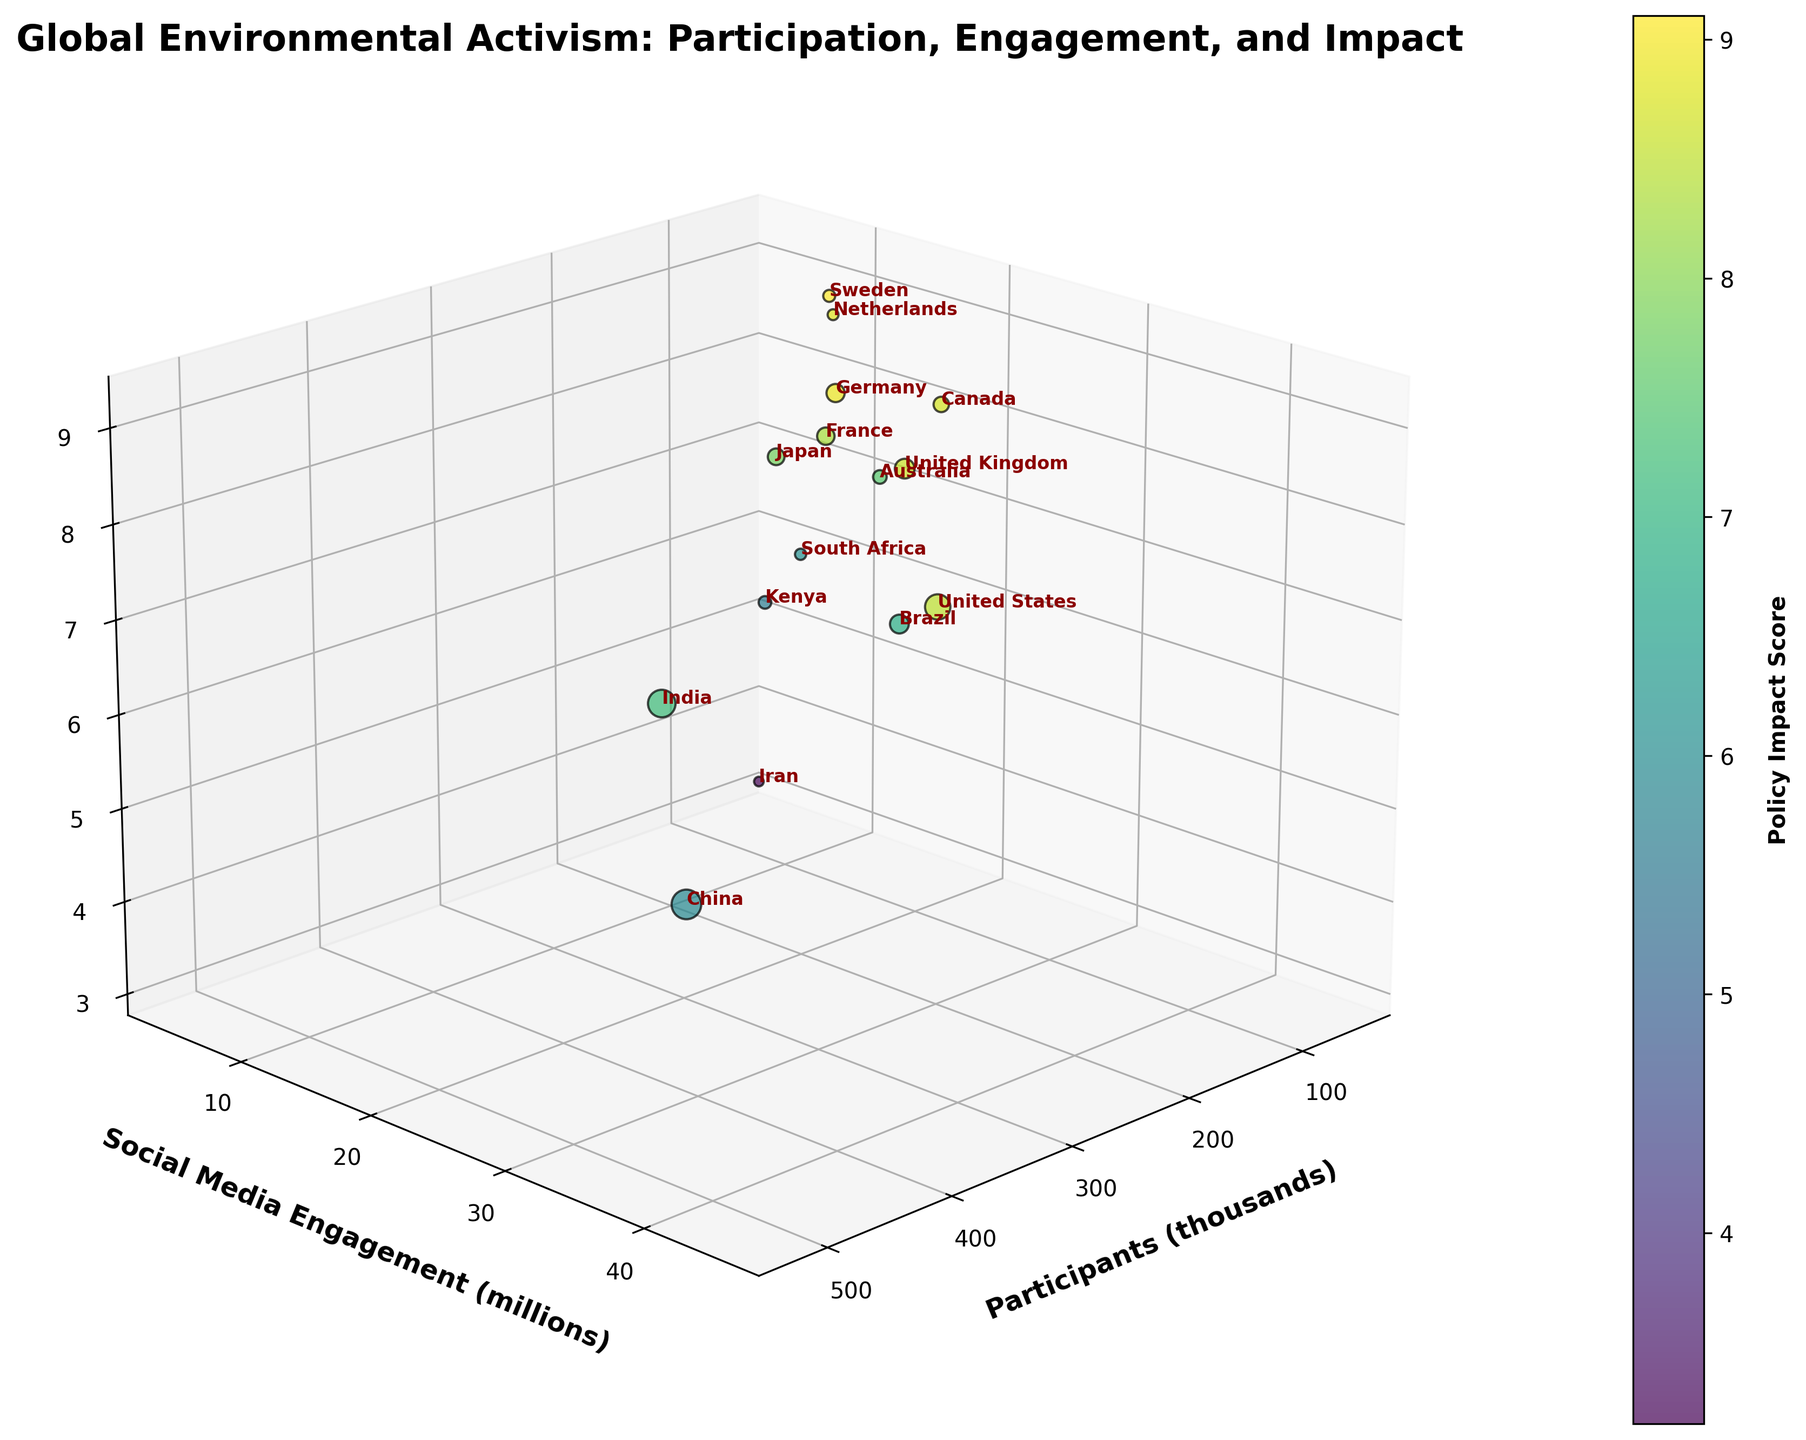What's the title of the figure? The title is prominently displayed at the top of the figure in bold text.
Answer: Global Environmental Activism: Participation, Engagement, and Impact Which country has the highest number of participants? The participants are represented on the x-axis, and the data point for China is the furthest to the right.
Answer: China What is the policy impact score for Sweden? Sweden's data point can be located by its label, and the z-axis value tells us the policy impact score.
Answer: 9.1 How many countries have a social media engagement above 20 million? The y-axis represents social media engagement, so we count the number of data points above 20 on the y-axis.
Answer: 7 Which country has the lowest policy impact score? The policy impact score is shown on the z-axis, and Iran is identified as the lowest point.
Answer: Iran Compare the social media engagement of India and United States. Look at the y-axis values for India and the United States, identified by their labels. India has 32 million, and the United States has 45 million.
Answer: United States What's the total number of participants from Australia and South Africa? Australia's participants are 110 thousand, and South Africa's are 75 thousand. Sum these numbers. 110 + 75 = 185.
Answer: 185 thousand Which countries have a policy impact score greater than 8.5? First, find the policy impact scores on the z-axis. The United States, Germany, Canada, and the United Kingdom each have scores greater than 8.5.
Answer: United States, Germany, Canada, United Kingdom Compare the policy impact scores of Brazil and Kenya. Locate Brazil and Kenya on the z-axis. Brazil has a score of 6.8, and Kenya has a score of 5.6.
Answer: Brazil What is the average social media engagement for countries under 100 participants? Countries under 100 participants: Sweden (12M), Kenya (8M), Iran (4M), South Africa (9M), Netherlands (11M). Calculate the average: (12+8+4+9+11)/5 = 8.8.
Answer: 8.8 million 